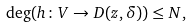Convert formula to latex. <formula><loc_0><loc_0><loc_500><loc_500>\deg ( h \colon V \rightarrow D ( z , \delta ) ) \leq N ,</formula> 